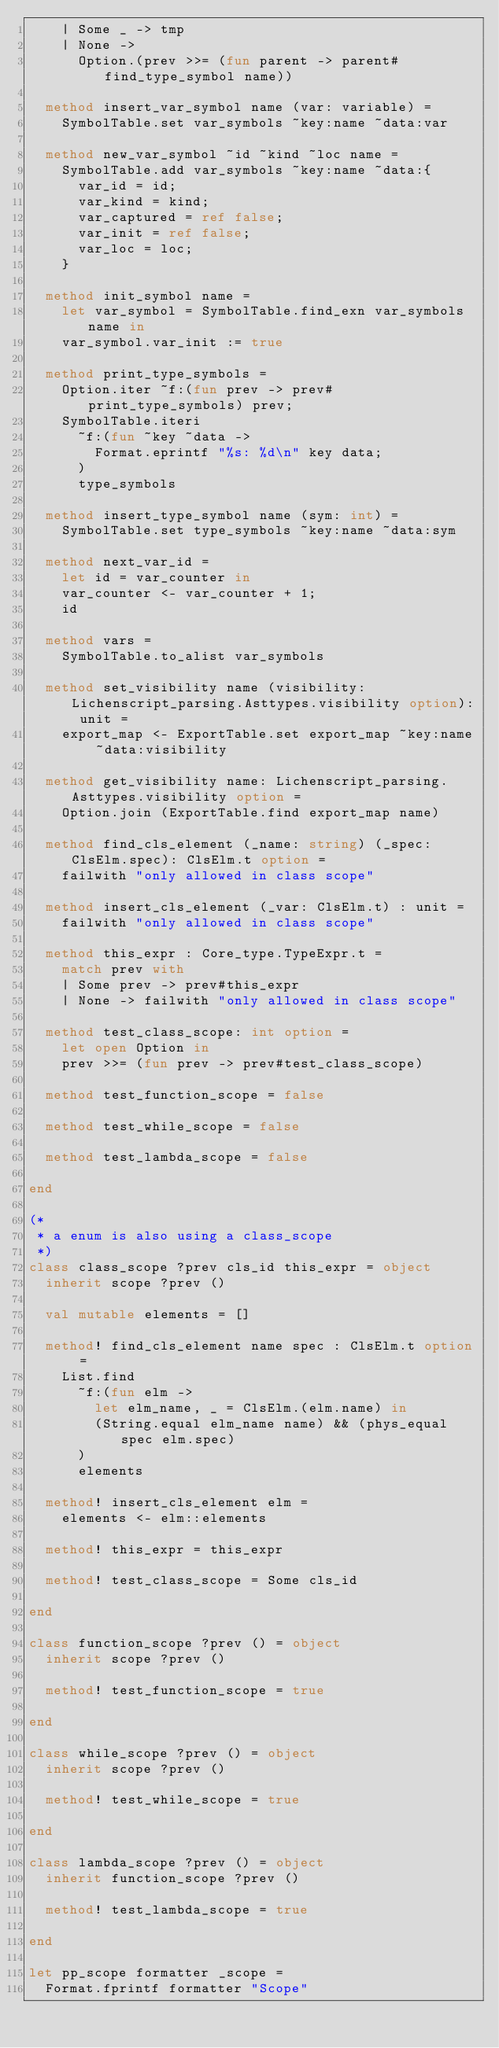<code> <loc_0><loc_0><loc_500><loc_500><_OCaml_>    | Some _ -> tmp
    | None ->
      Option.(prev >>= (fun parent -> parent#find_type_symbol name))

  method insert_var_symbol name (var: variable) =
    SymbolTable.set var_symbols ~key:name ~data:var

  method new_var_symbol ~id ~kind ~loc name =
    SymbolTable.add var_symbols ~key:name ~data:{
      var_id = id;
      var_kind = kind;
      var_captured = ref false;
      var_init = ref false;
      var_loc = loc;
    }

  method init_symbol name =
    let var_symbol = SymbolTable.find_exn var_symbols name in
    var_symbol.var_init := true

  method print_type_symbols =
    Option.iter ~f:(fun prev -> prev#print_type_symbols) prev;
    SymbolTable.iteri
      ~f:(fun ~key ~data ->
        Format.eprintf "%s: %d\n" key data;
      )
      type_symbols

  method insert_type_symbol name (sym: int) =
    SymbolTable.set type_symbols ~key:name ~data:sym

  method next_var_id =
    let id = var_counter in
    var_counter <- var_counter + 1;
    id

  method vars =
    SymbolTable.to_alist var_symbols

  method set_visibility name (visibility: Lichenscript_parsing.Asttypes.visibility option): unit =
    export_map <- ExportTable.set export_map ~key:name ~data:visibility

  method get_visibility name: Lichenscript_parsing.Asttypes.visibility option =
    Option.join (ExportTable.find export_map name)

  method find_cls_element (_name: string) (_spec: ClsElm.spec): ClsElm.t option =
    failwith "only allowed in class scope"

  method insert_cls_element (_var: ClsElm.t) : unit =
    failwith "only allowed in class scope"

  method this_expr : Core_type.TypeExpr.t =
    match prev with
    | Some prev -> prev#this_expr
    | None -> failwith "only allowed in class scope"

  method test_class_scope: int option =
    let open Option in
    prev >>= (fun prev -> prev#test_class_scope)

  method test_function_scope = false

  method test_while_scope = false

  method test_lambda_scope = false

end

(*
 * a enum is also using a class_scope
 *)
class class_scope ?prev cls_id this_expr = object
  inherit scope ?prev ()

  val mutable elements = []

  method! find_cls_element name spec : ClsElm.t option =
    List.find
      ~f:(fun elm ->
        let elm_name, _ = ClsElm.(elm.name) in
        (String.equal elm_name name) && (phys_equal spec elm.spec)
      )
      elements

  method! insert_cls_element elm =
    elements <- elm::elements

  method! this_expr = this_expr

  method! test_class_scope = Some cls_id

end

class function_scope ?prev () = object
  inherit scope ?prev ()

  method! test_function_scope = true

end

class while_scope ?prev () = object
  inherit scope ?prev ()

  method! test_while_scope = true

end

class lambda_scope ?prev () = object
  inherit function_scope ?prev ()

  method! test_lambda_scope = true

end

let pp_scope formatter _scope =
  Format.fprintf formatter "Scope"
</code> 